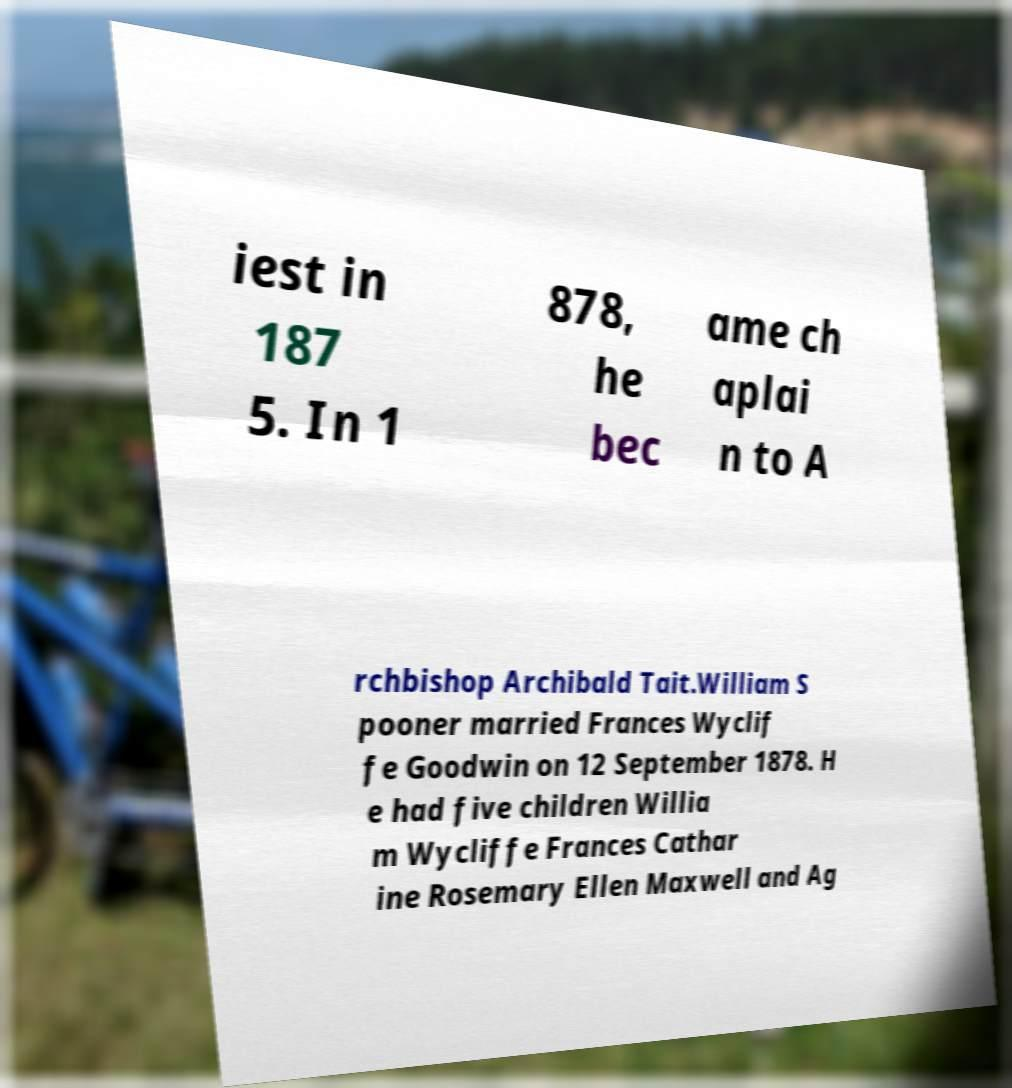Could you extract and type out the text from this image? iest in 187 5. In 1 878, he bec ame ch aplai n to A rchbishop Archibald Tait.William S pooner married Frances Wyclif fe Goodwin on 12 September 1878. H e had five children Willia m Wycliffe Frances Cathar ine Rosemary Ellen Maxwell and Ag 